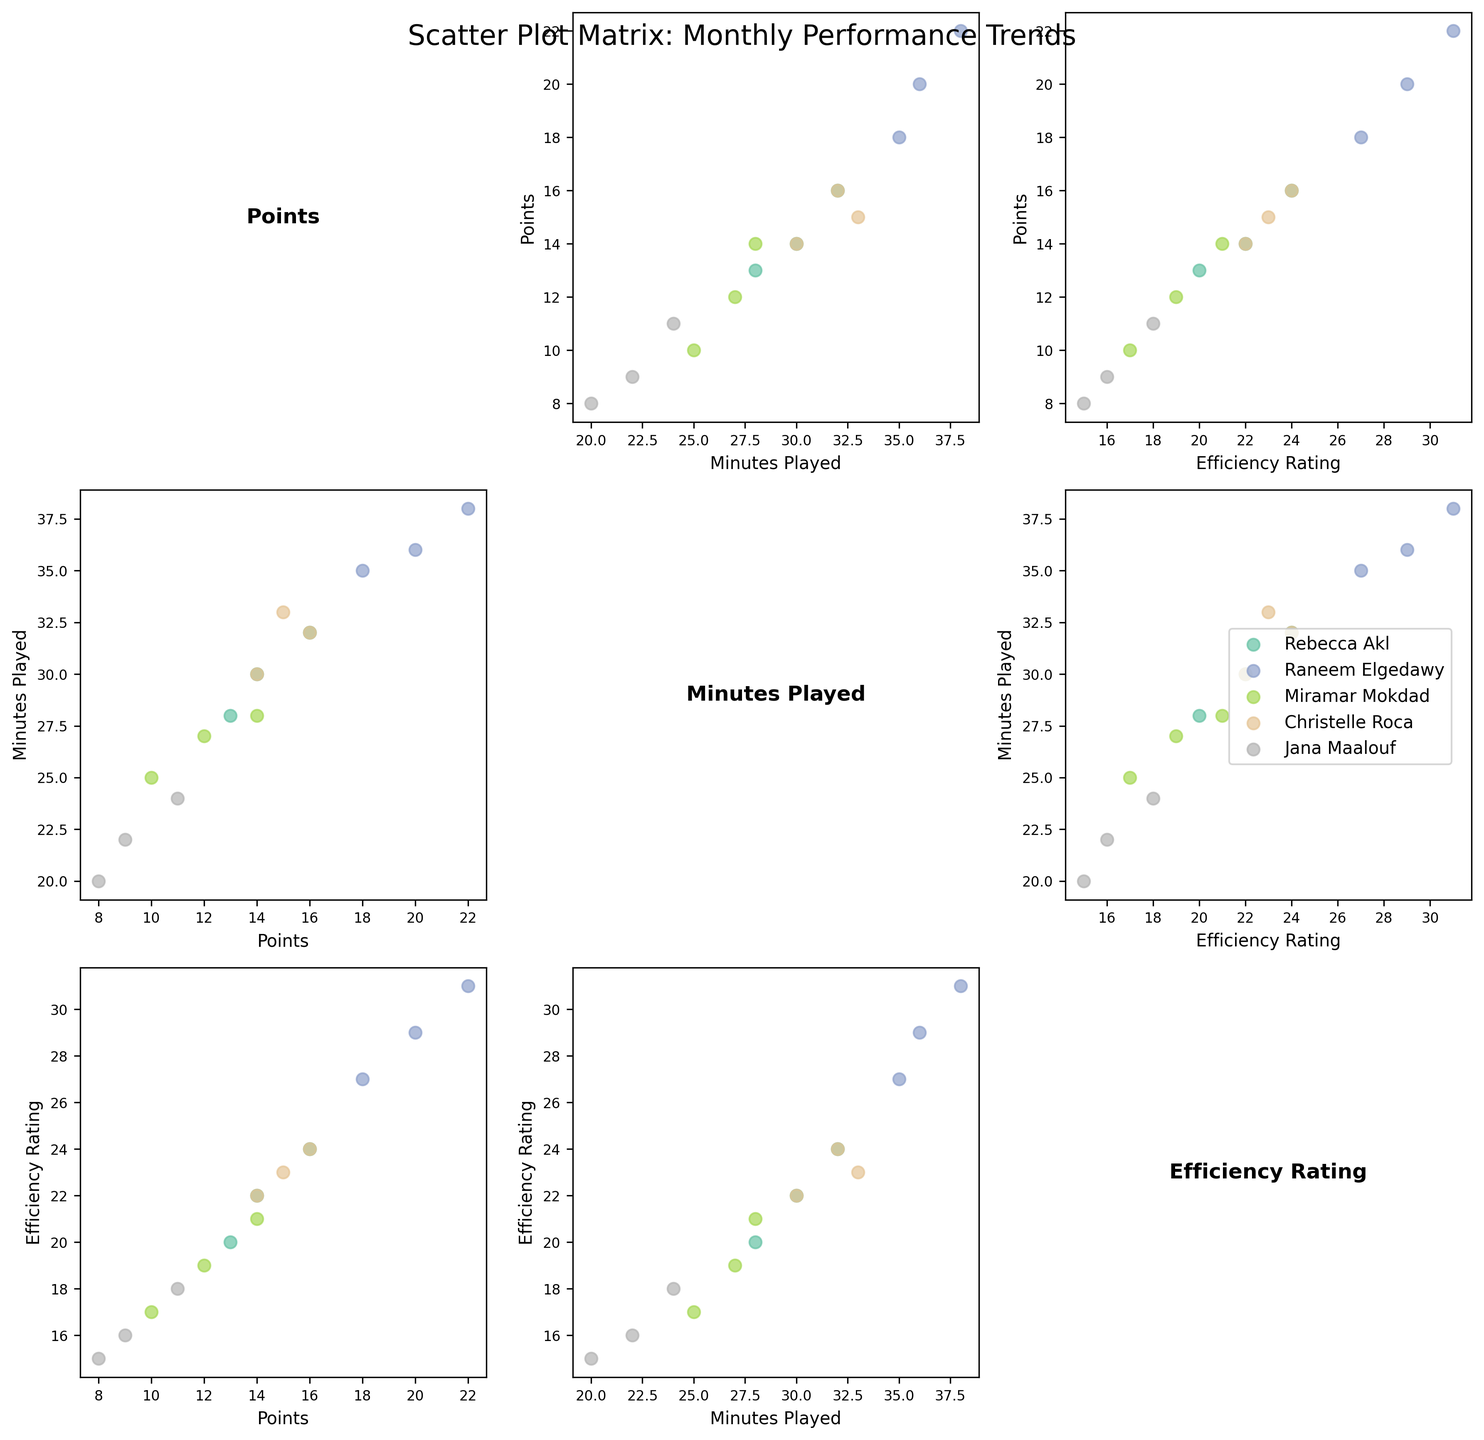What is the title of the Scatter Plot Matrix (SPLOM)? The title of the SPLOM is located at the top center of the figure.
Answer: Scatter Plot Matrix: Monthly Performance Trends How many players are represented in the figure? Each unique color represents a different player, and the legend to the right of the plot lists all the players. There are five players.
Answer: Five Which player has the highest Efficiency Rating in March? You need to locate the Efficiency Rating vs. Month subplot and identify the point in March with the highest Efficiency Rating, and check the color and label that match this point.
Answer: Raneem Elgedawy On average, which player plays the most minutes per month? For each player, add their 'Minutes Played' values across all months and then divide by the number of months to find the average. The player with the highest average is the answer.
Answer: Raneem Elgedawy Is there a visible correlation between Points scored and Efficiency Rating? Look at the Points vs. Efficiency Rating subplot. If the points generally form an upward line, there is a positive correlation.
Answer: Yes, a positive correlation Who showed the most increase in Points scored from January to March? Calculate the difference in Points from March and January for each player and see which player has the largest increase.
Answer: Raneem Elgedawy Do players with higher Efficiency Ratings tend to play more minutes? Examine the Efficiency Rating vs. Minutes Played subplot. If points form an upward-sloping pattern, players with high Efficiency Ratings tend to play more minutes.
Answer: Yes Which two players have the closest Efficiency Ratings in February? Identify the Efficiency Ratings in February for all players and compare them to find the two closest values.
Answer: Rebecca Akl and Christelle Roca What are the median Minutes Played for all players in February? List the 'Minutes Played' values for each player in February, arrange them in ascending order, and identify the median value.
Answer: 28 minutes Which player has the lowest average Efficiency Rating across the months? For each player, add their 'Efficiency Rating' values across all months and divide by the number of months. Identify the lowest average value.
Answer: Jana Maalouf 